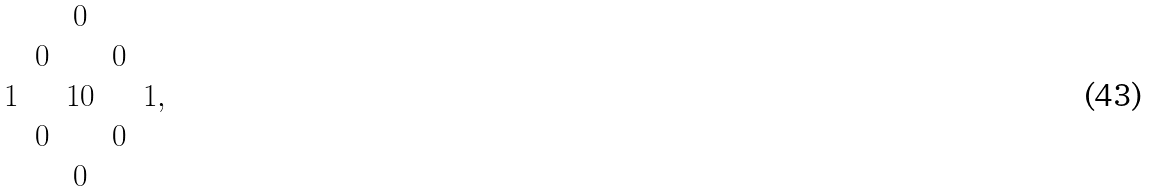Convert formula to latex. <formula><loc_0><loc_0><loc_500><loc_500>\begin{matrix} & & 0 \\ & 0 & & 0 \\ 1 & & 1 0 & & 1 , \\ & 0 & & 0 \\ & & 0 \end{matrix}</formula> 